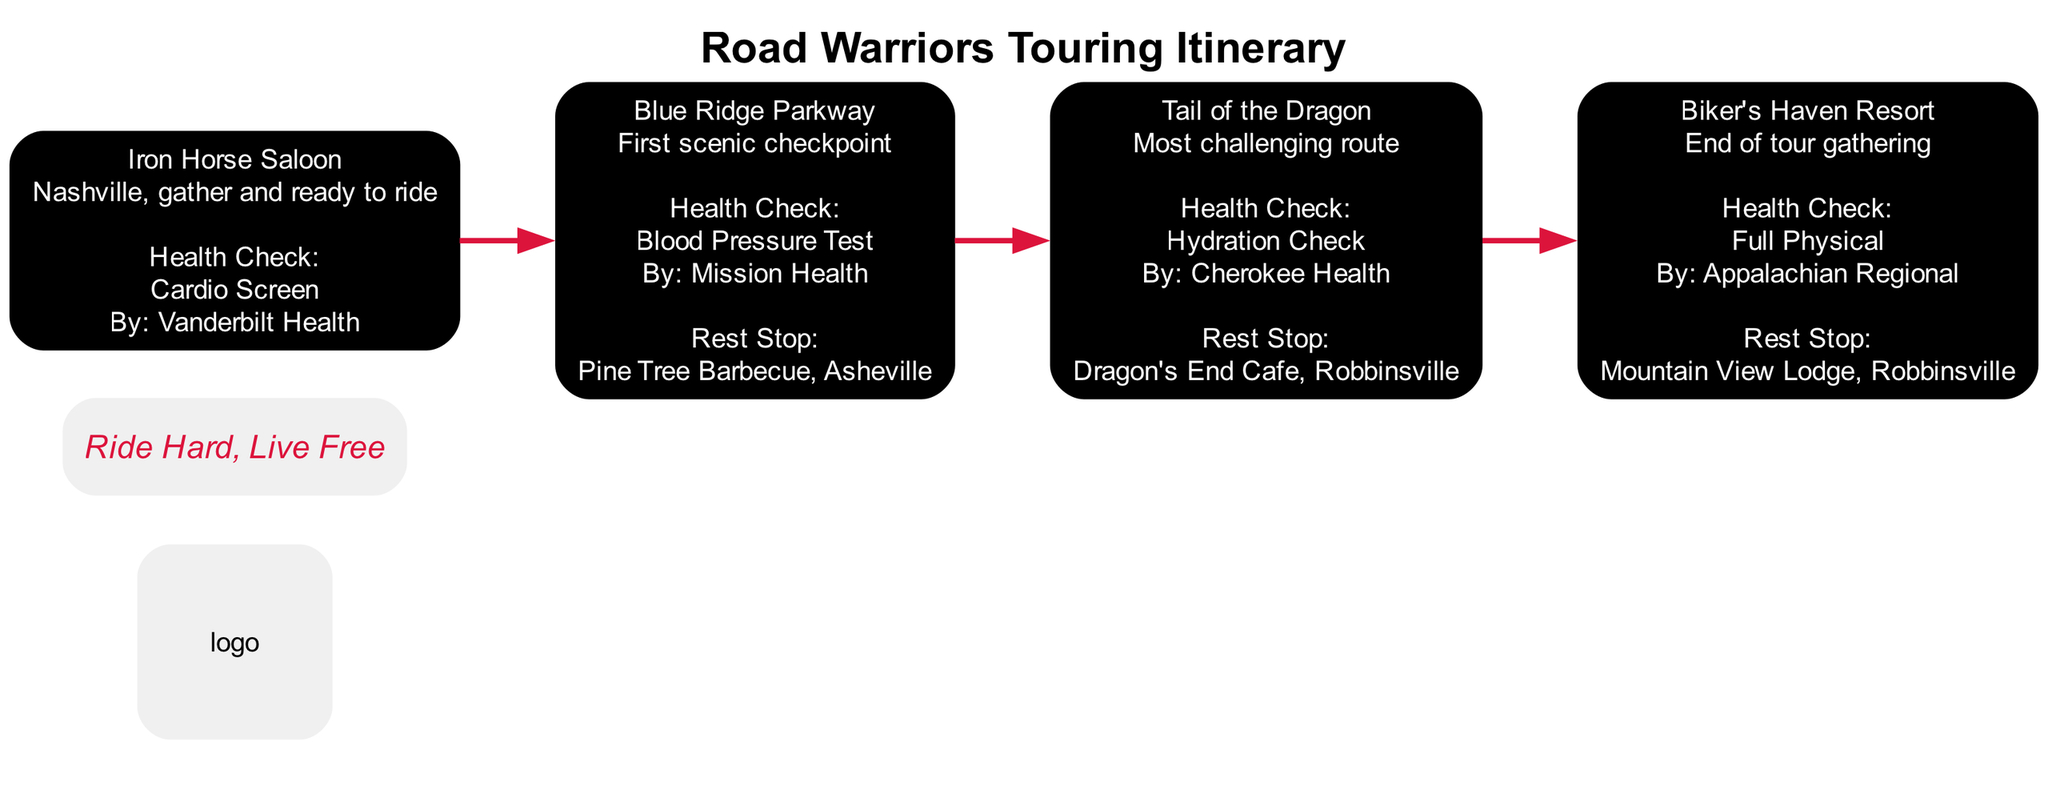What's the starting location of the tour? The starting location is clearly labeled as "Iron Horse Saloon" in the diagram under the "StartPoint" stage.
Answer: Iron Horse Saloon How many health checks are conducted during the event? There are three distinct health checks mentioned in the diagram, each corresponding to a different checkpoint or stop point. They are identified in the Health Check sections of the respective stages.
Answer: 3 What type of health check is conducted at the first checkpoint? The first checkpoint specifies "Blood Pressure Test" as the type of health check, which is provided under the "Checkpoint1" stage.
Answer: Blood Pressure Test What is the rest stop located at the second checkpoint? In the diagram, "Dragon's End Cafe, Robbinsville" is listed as the rest stop under the "Checkpoint2" stage.
Answer: Dragon's End Cafe, Robbinsville Which health check is conducted at the end of the tour? The diagram indicates that a "Full Physical" is the health check conducted at the "StopPoint" stage, identified as the end of the tour.
Answer: Full Physical What is the motto of the motorcycle club? The motto is prominently displayed in the diagram and is part of the identity elements of the touring event.
Answer: Ride Hard, Live Free How many stages are there in the itinerary? The diagram outlines four stages: StartPoint, Checkpoint1, Checkpoint2, and StopPoint, all of which can be counted from the visual layout.
Answer: 4 What is the theme color for the touring event? The diagram highlights "Black" as one of the theme colors in the identity elements.
Answer: Black What location serves as the final gathering stop? The final gathering location is named "Biker's Haven Resort," as indicated in the "StopPoint" stage of the diagram.
Answer: Biker's Haven Resort 